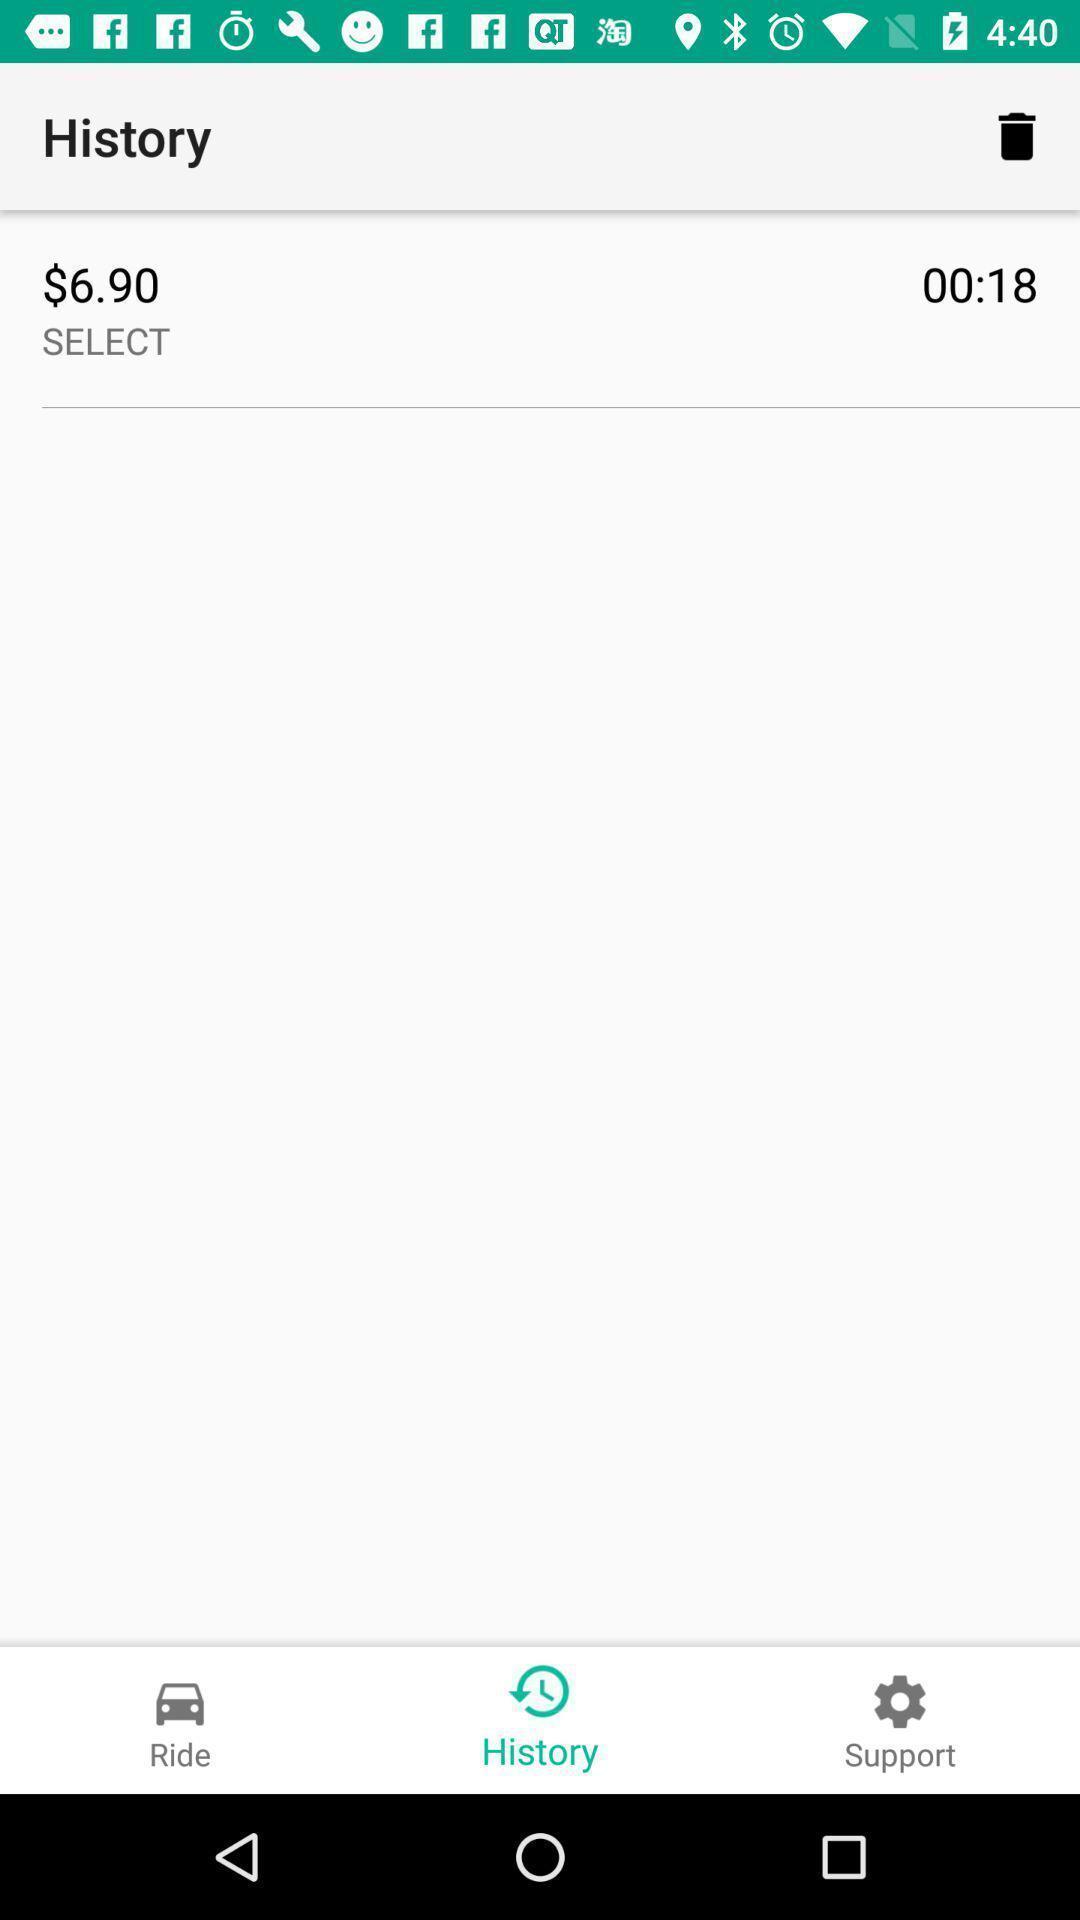Tell me about the visual elements in this screen capture. Screen shows history. 